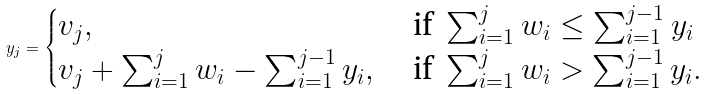<formula> <loc_0><loc_0><loc_500><loc_500>y _ { j } = \begin{cases} v _ { j } , & \text { if } \sum _ { i = 1 } ^ { j } w _ { i } \leq \sum _ { i = 1 } ^ { j - 1 } y _ { i } \\ v _ { j } + \sum _ { i = 1 } ^ { j } w _ { i } - \sum _ { i = 1 } ^ { j - 1 } y _ { i } , & \text { if } \sum _ { i = 1 } ^ { j } w _ { i } > \sum _ { i = 1 } ^ { j - 1 } y _ { i } . \end{cases}</formula> 